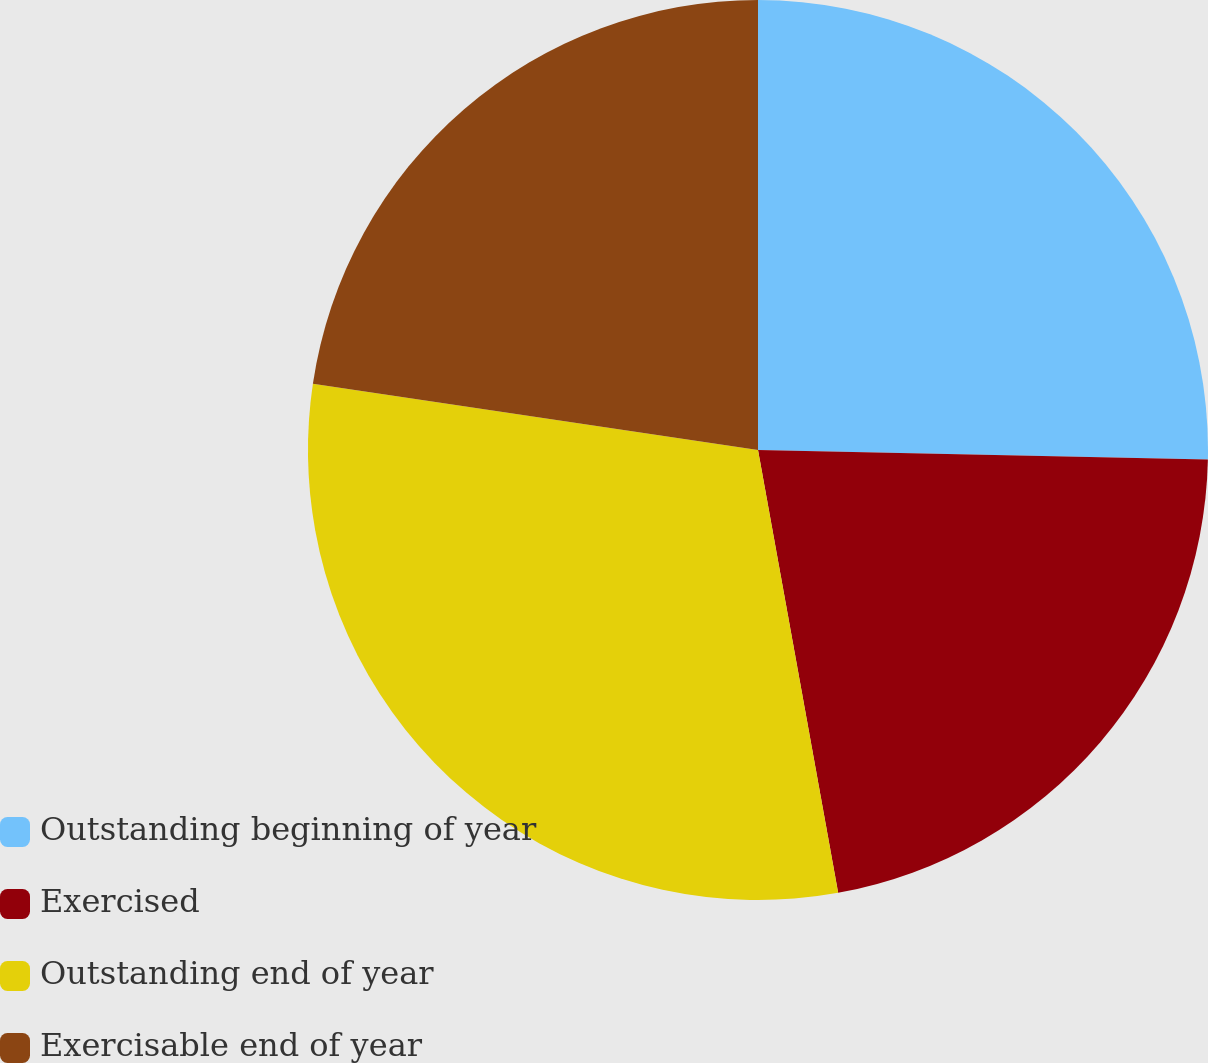Convert chart to OTSL. <chart><loc_0><loc_0><loc_500><loc_500><pie_chart><fcel>Outstanding beginning of year<fcel>Exercised<fcel>Outstanding end of year<fcel>Exercisable end of year<nl><fcel>25.34%<fcel>21.81%<fcel>30.2%<fcel>22.65%<nl></chart> 